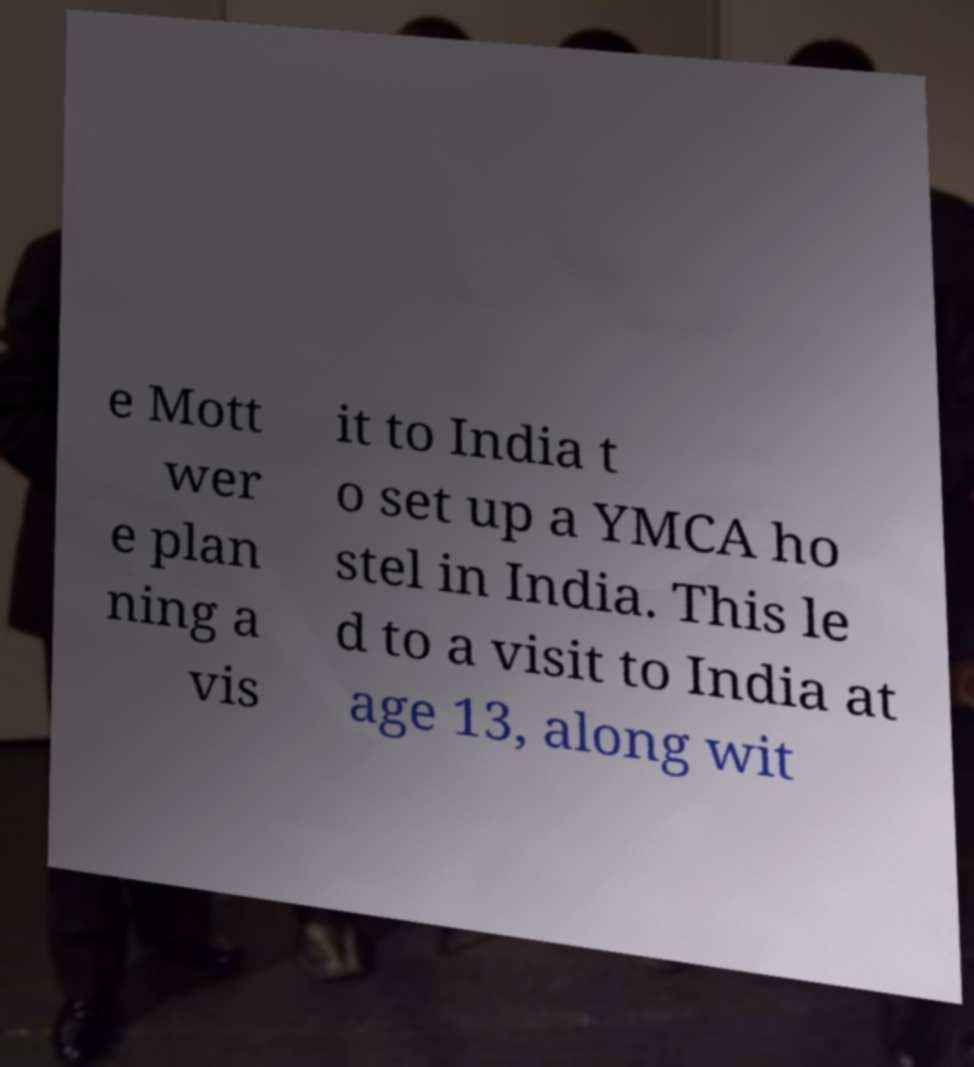Could you assist in decoding the text presented in this image and type it out clearly? e Mott wer e plan ning a vis it to India t o set up a YMCA ho stel in India. This le d to a visit to India at age 13, along wit 